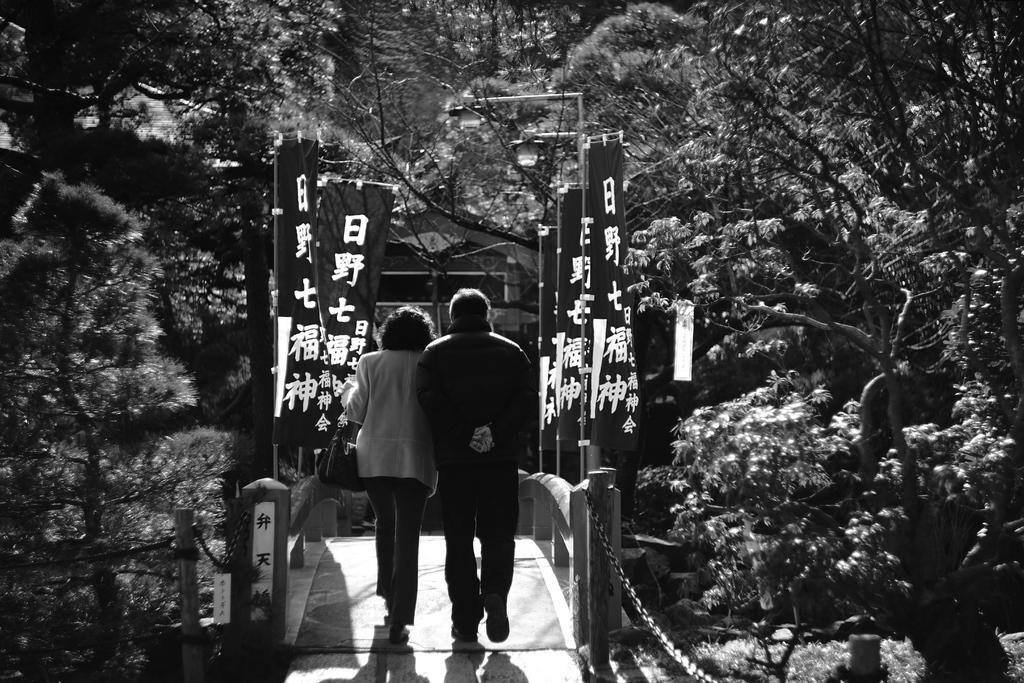In one or two sentences, can you explain what this image depicts? There are two persons walking. This is a iron chain and the flags. There are many trees around. 